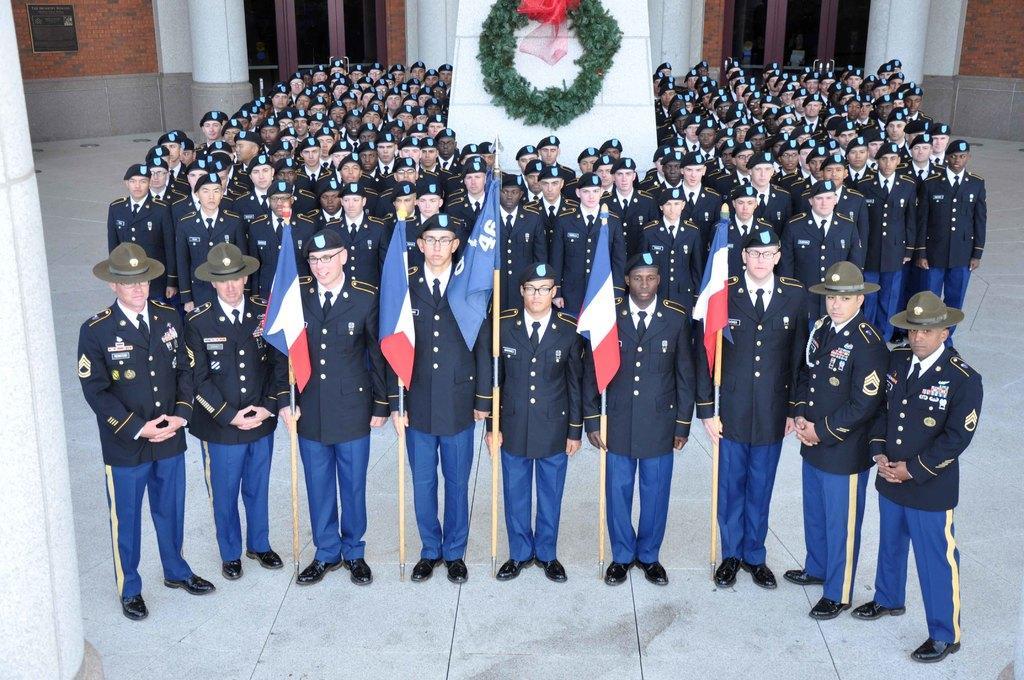In one or two sentences, can you explain what this image depicts? In this image, I can see a group of people standing. Among them five persons are holding the flags. At the top of the image, I can see a wreath attached to the wall. In the background, there is a building with doors and pillars. 